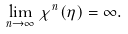Convert formula to latex. <formula><loc_0><loc_0><loc_500><loc_500>\lim _ { n \rightarrow \infty } \chi ^ { n } ( \eta ) = \infty .</formula> 